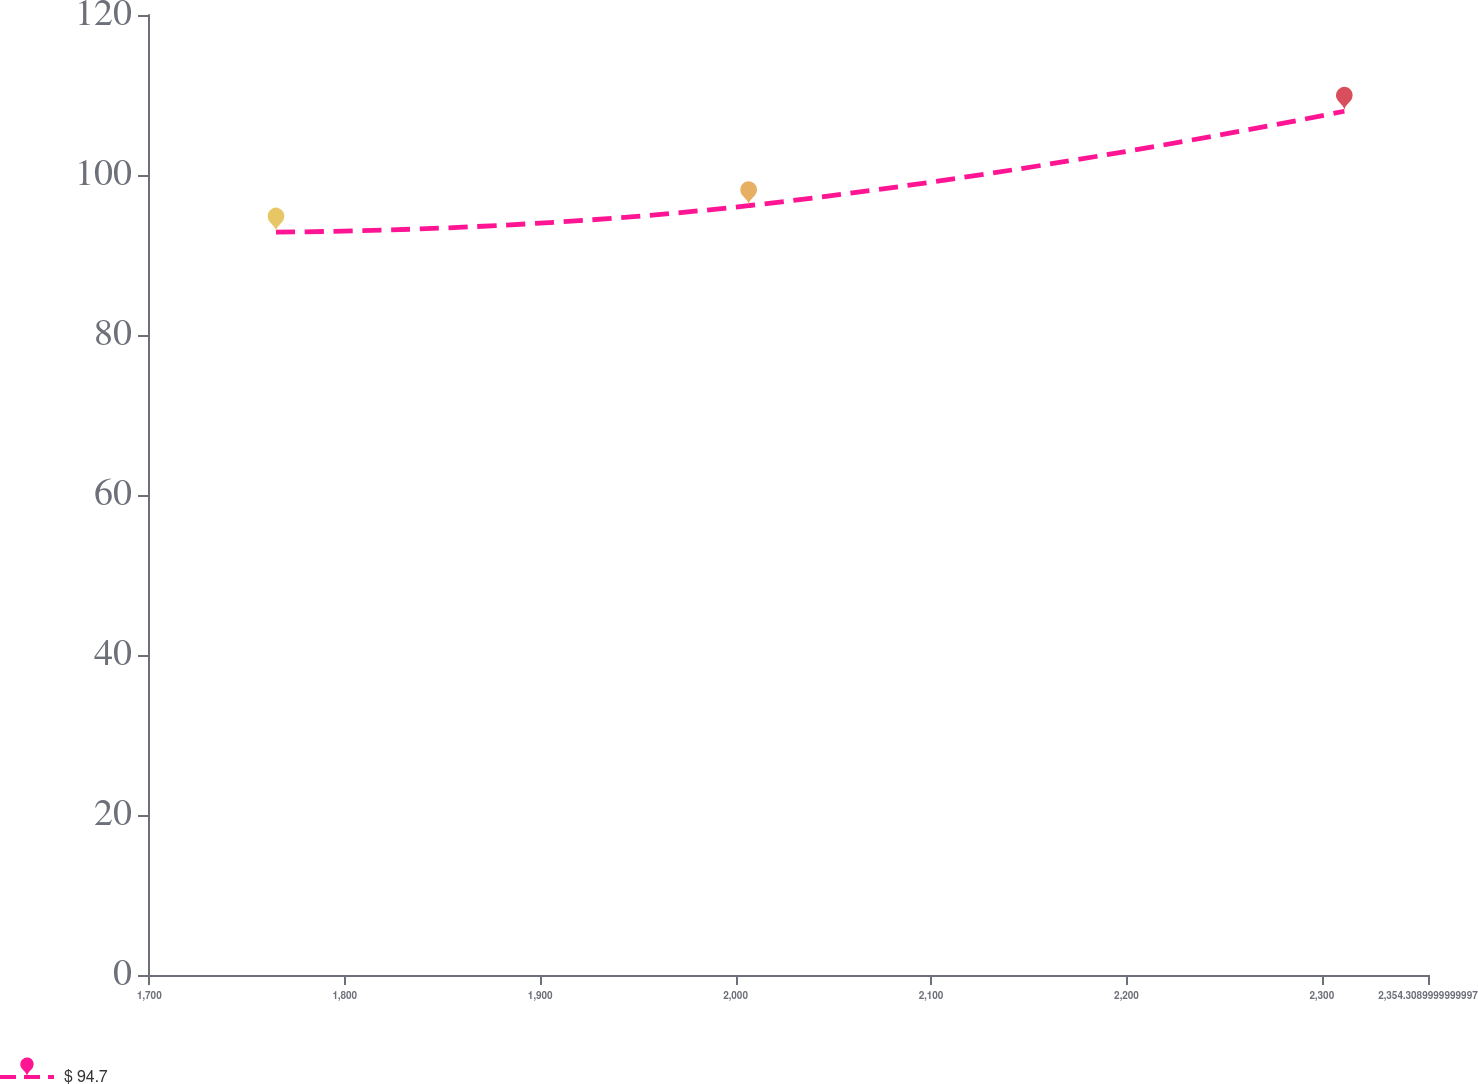Convert chart. <chart><loc_0><loc_0><loc_500><loc_500><line_chart><ecel><fcel>$ 94.7<nl><fcel>1764.8<fcel>92.87<nl><fcel>2006.66<fcel>96.17<nl><fcel>2311.5<fcel>107.97<nl><fcel>2419.81<fcel>78.38<nl></chart> 